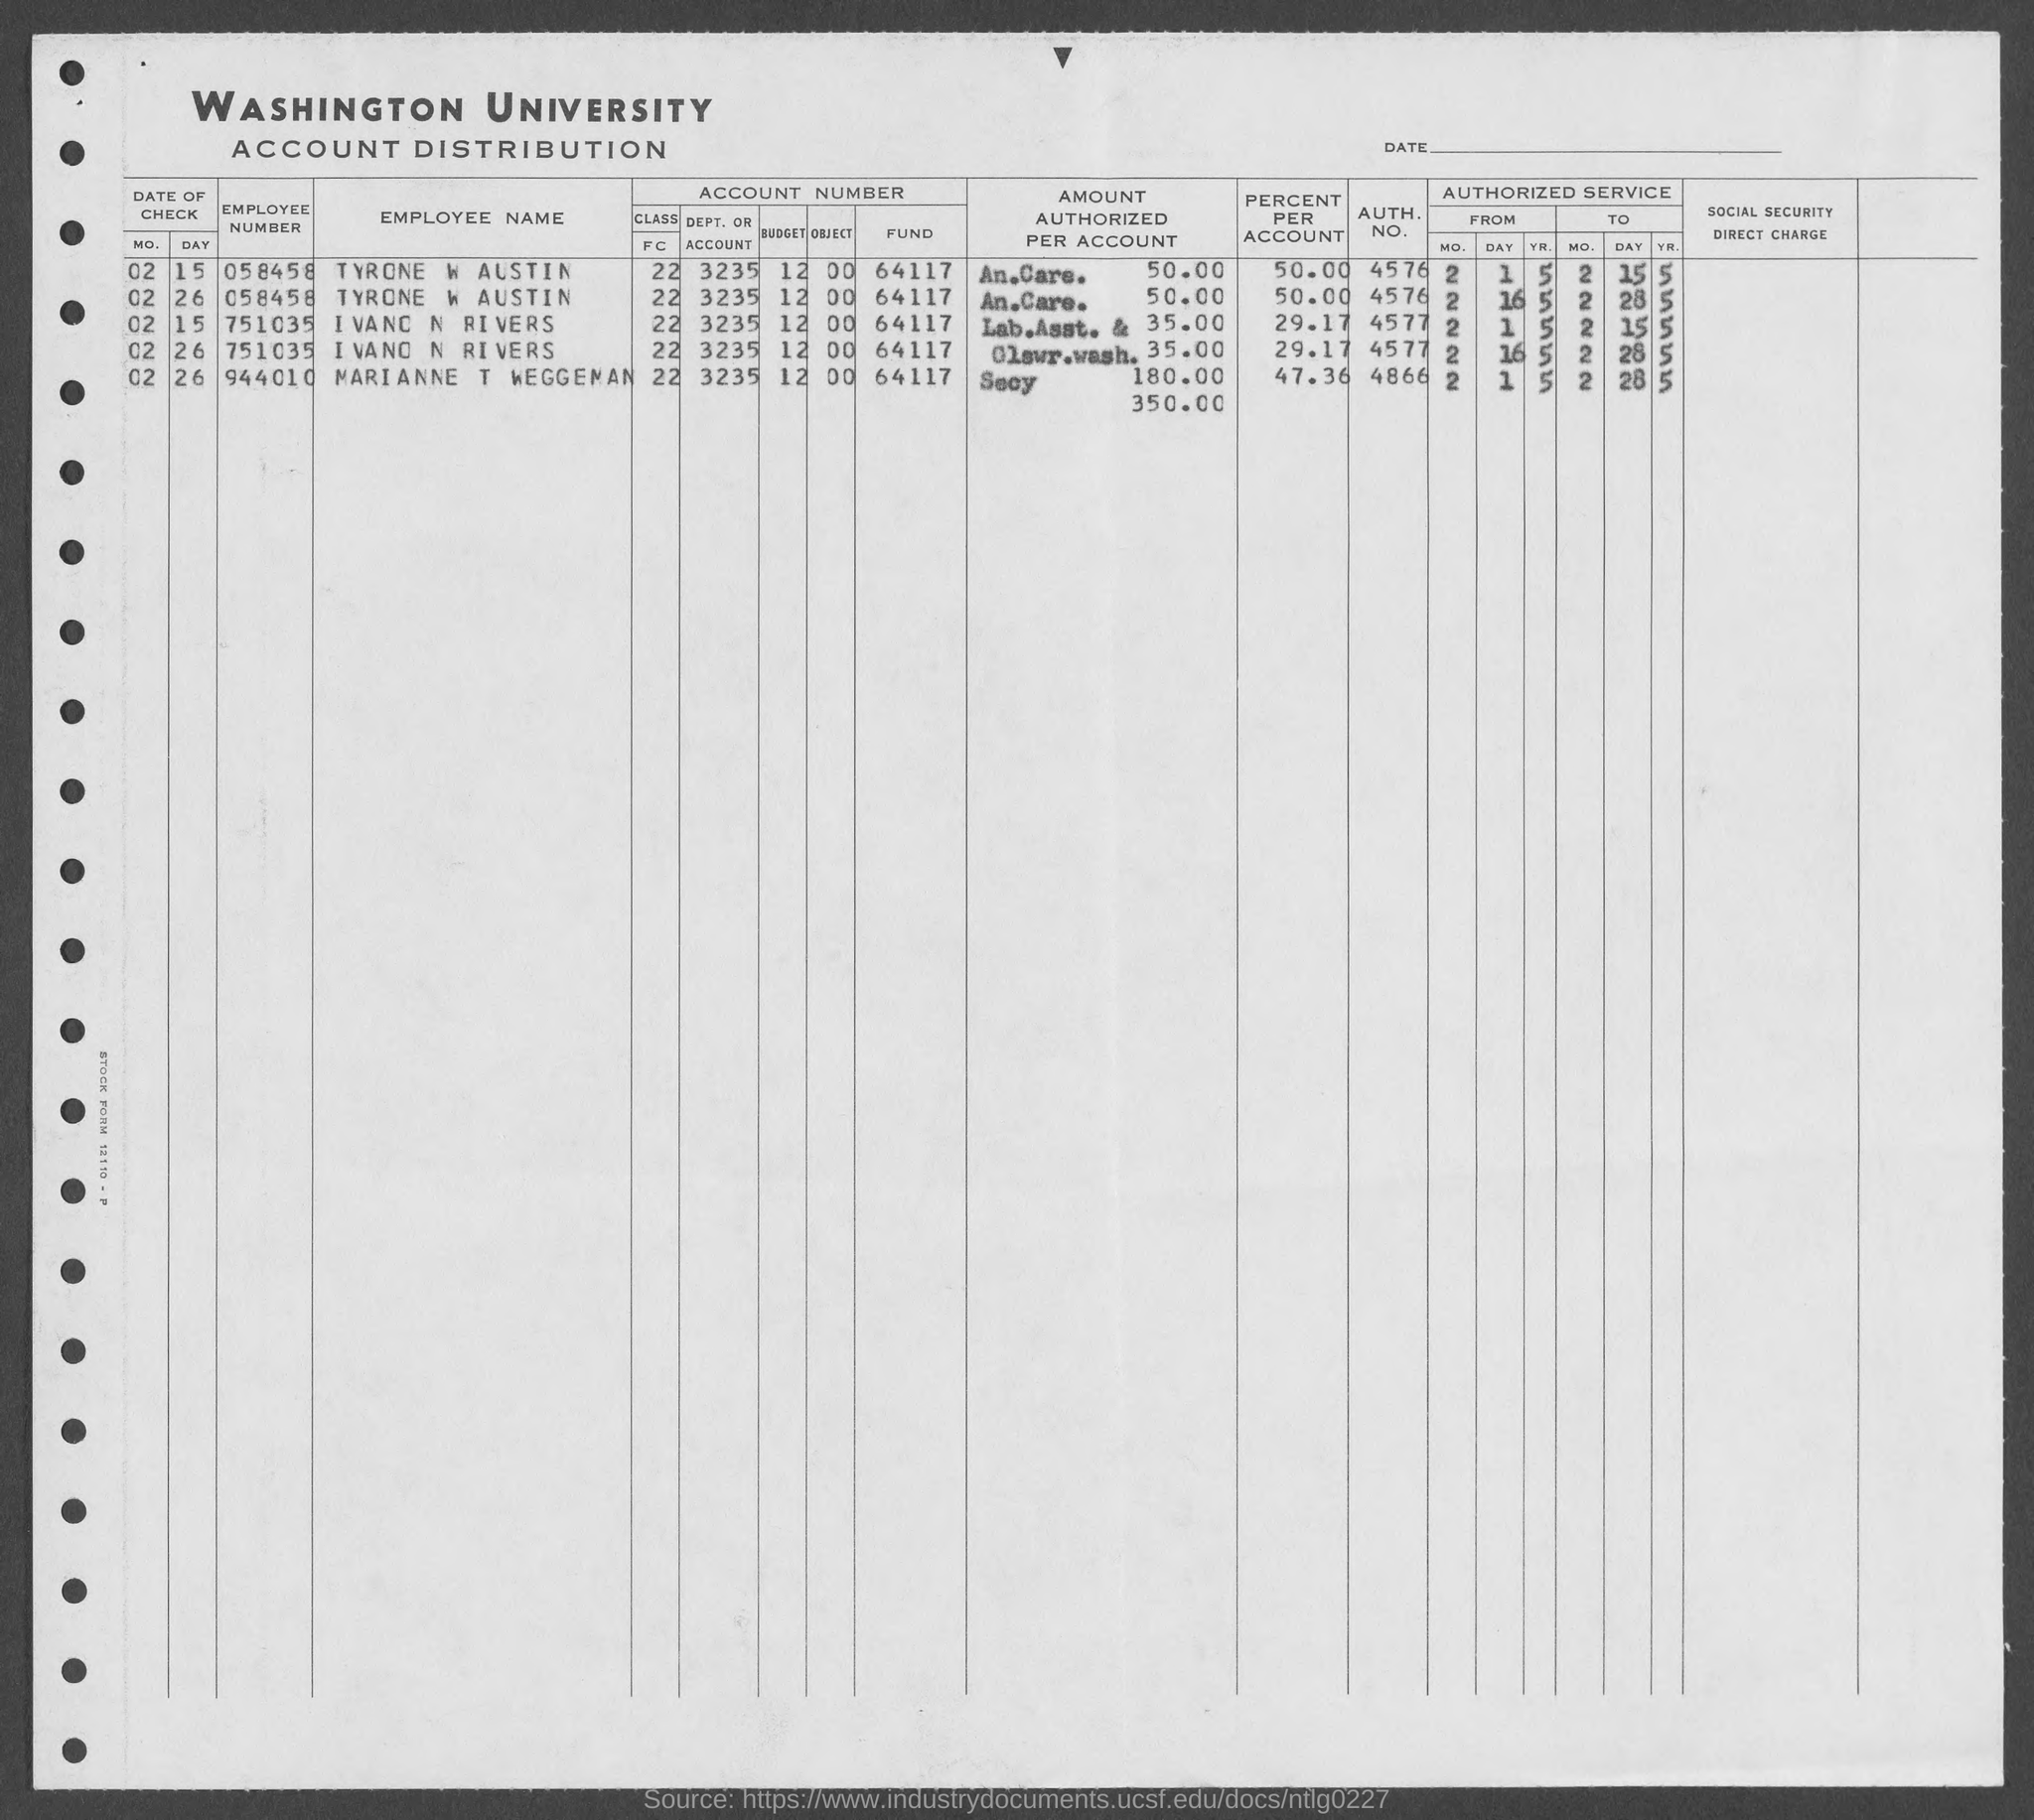Point out several critical features in this image. The employee number of TYRONE W AUSTIN, as listed in the document, is 058458. Out of every account, TYRONE W AUSTIN holds 50.00%. The AUTH. NO. of IVANO N RIVERS mentioned in the document is 4577.. The AUTH. NO. of TYRONE W AUSTIN as listed in the document is 4576. The employee number of Ivano N Rivers, as listed in the document, is 751035. 